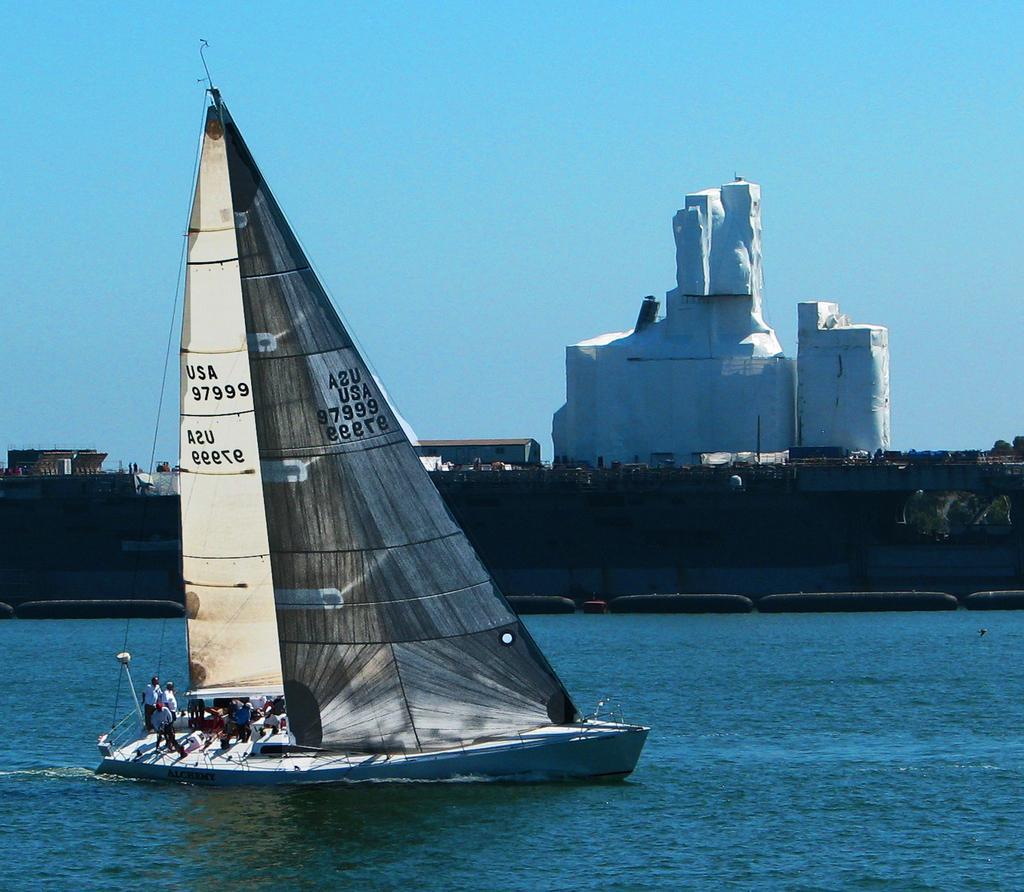Could you give a brief overview of what you see in this image? In the image there is a ship sailing on the water and there is a big mast to the ship and in front of the mast there are some people and behind the sea there is a bridge and on the bridge there is a big construction. 